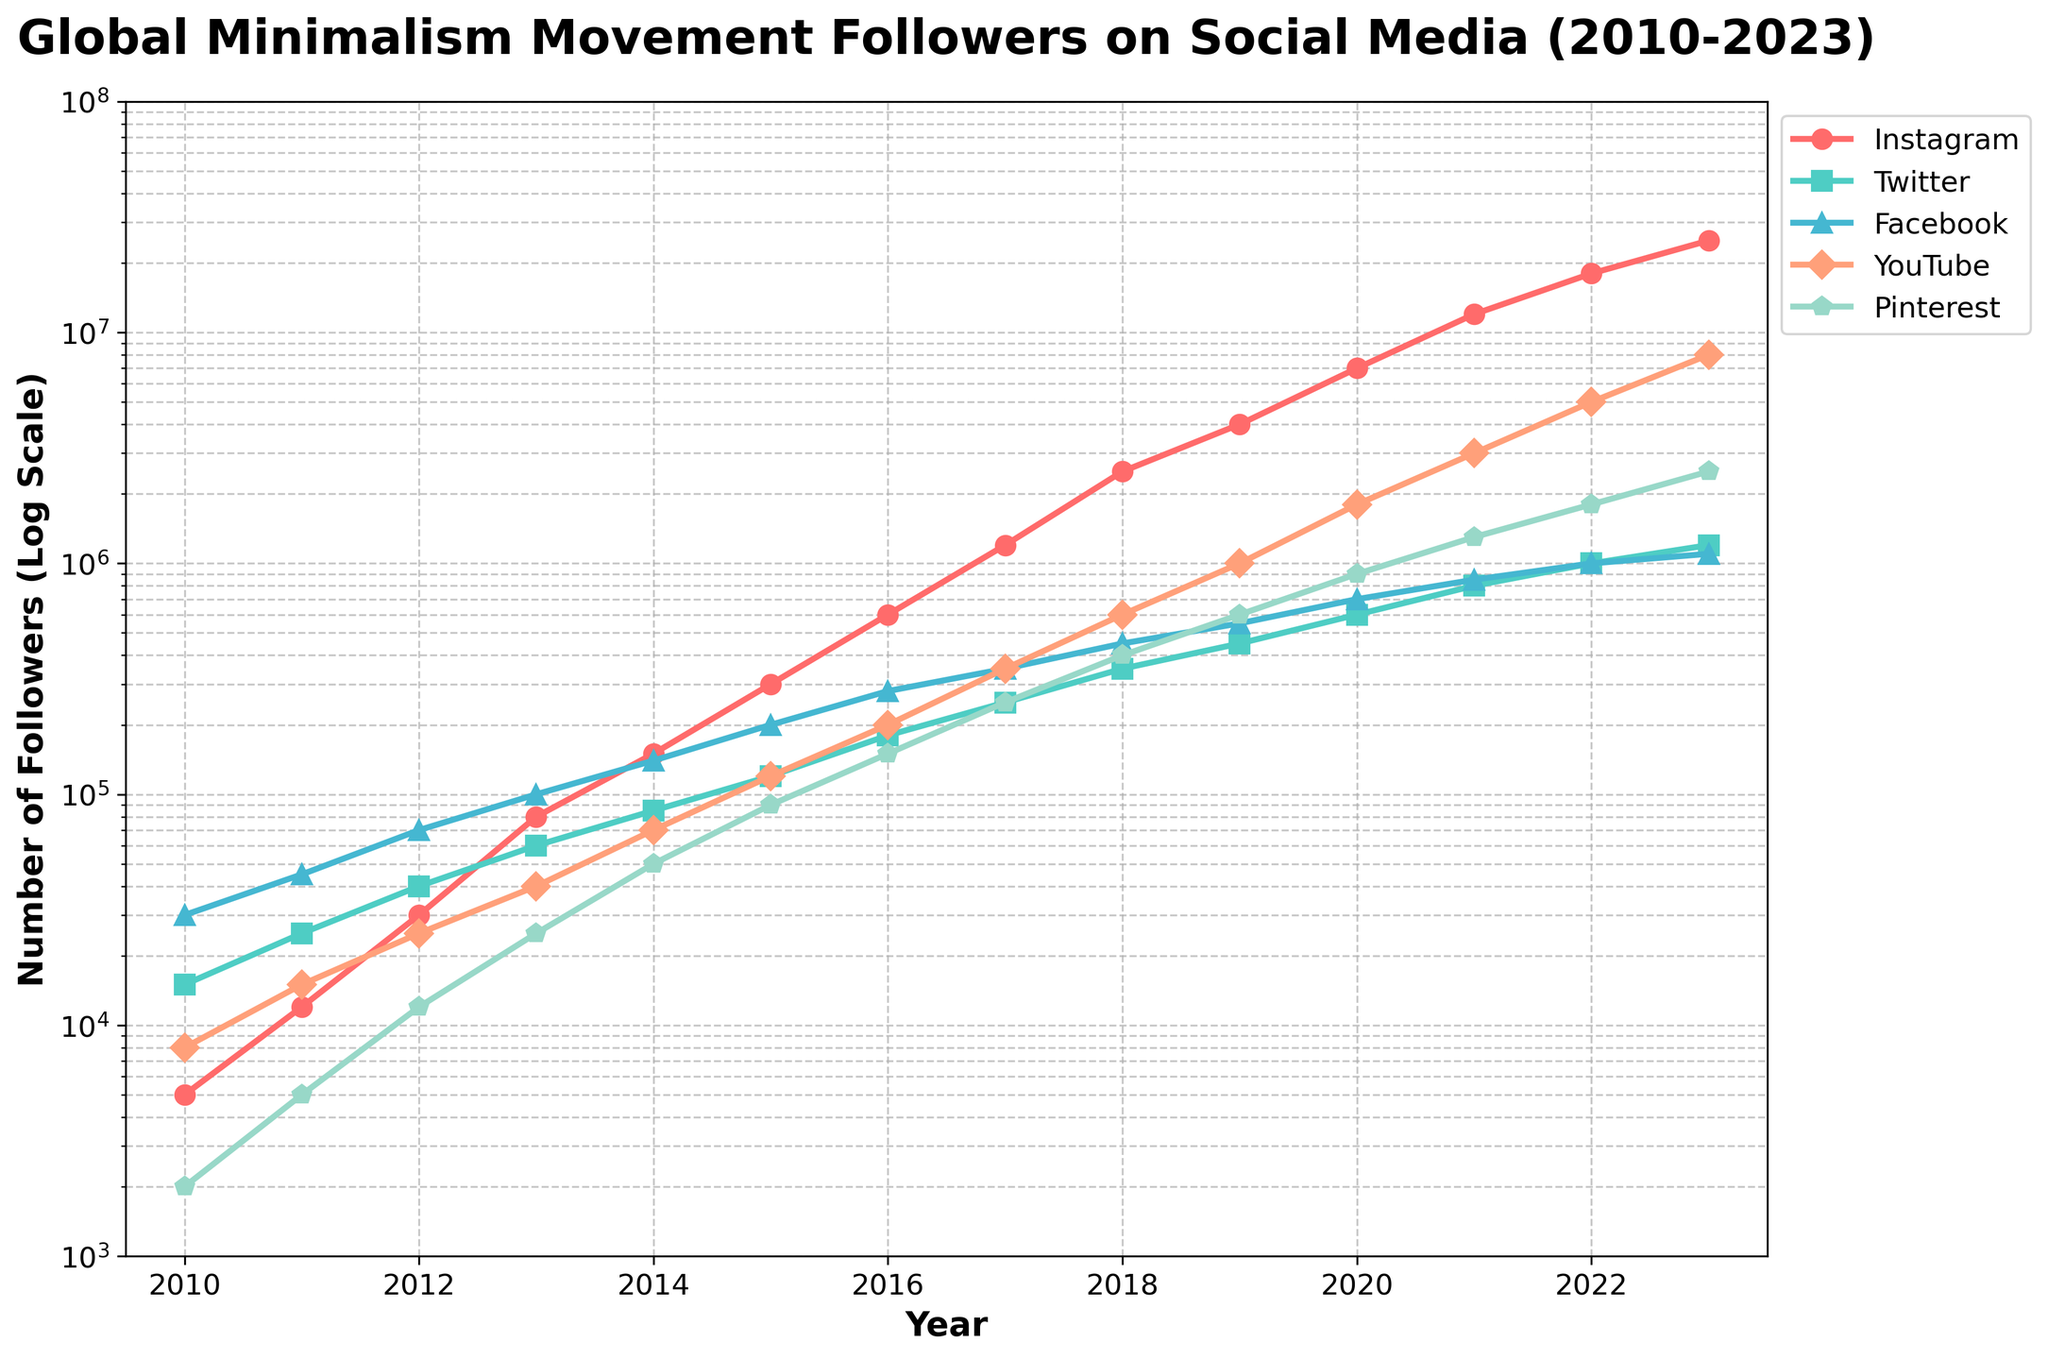What was the total number of followers on Instagram in 2020 and 2021 combined? The values for Instagram followers in 2020 and 2021 are 7,000,000 and 12,000,000, respectively. Adding them together: 7,000,000 + 12,000,000 = 19,000,000
Answer: 19,000,000 Which social media platform had the highest number of followers in 2017? Looking at the data for 2017, Instagram had 1,200,000 followers, Twitter had 250,000, Facebook had 350,000, YouTube had 350,000, and Pinterest had 250,000. Therefore, Instagram had the highest number of followers in 2017
Answer: Instagram Between which two consecutive years did YouTube experience the highest growth in followers? To find this, we need to compare the yearly differences. The differences in YouTube followers are: 2010-2011: 7,000, 2011-2012: 10,000, 2012-2013: 15,000, 2013-2014: 30,000, 2014-2015: 50,000, 2015-2016: 80,000, 2016-2017: 150,000, 2017-2018: 250,000, 2018-2019: 400,000, 2019-2020: 800,000, 2020-2021: 1,200,000, 2021-2022: 2,000,000, 2022-2023: 3,000,000. The highest growth is from 2021 to 2022
Answer: 2021 to 2022 What is the relative growth rate in followers for Pinterest from 2010 to 2023? Calculate the relative growth rate: (2023 followers - 2010 followers) / 2010 followers. For Pinterest, this is (2,500,000 - 2,000) / 2,000 = 1,248.5
Answer: 1,248.5 Which year did Facebook have 100,000 followers? According to the data, Facebook reached 100,000 followers in 2013
Answer: 2013 What is the compound annual growth rate (CAGR) of Twitter followers from 2010 to 2023? To calculate CAGR, we use the formula: CAGR = (Ending value / Beginning value)^(1 / number of years) - 1. For Twitter, (1,200,000 / 15,000)^(1 / 13) - 1 ≈ 0.49
Answer: 0.49 (or 49%) How many more followers did Instagram have than Facebook in 2023? Instagram had 25,000,000 followers and Facebook had 1,100,000 in 2023. The difference: 25,000,000 - 1,100,000 = 23,900,000
Answer: 23,900,000 Which social media platform experienced the sharpest increase (visible by the steepest curve) from 2018 to 2023? The curve for Instagram from 2018 to 2023 shows the steepest increase compared to the other platforms
Answer: Instagram Are there any years where the number of followers on Twitter was higher than that on Facebook? If so, which years? Comparing the followers each year, Twitter had more followers than Facebook in 2010, 2011, and 2012
Answer: 2010, 2011, 2012 In which year did Pinterest followers surpass 1 million? According to the data, Pinterest followers surpassed 1 million in 2021
Answer: 2021 